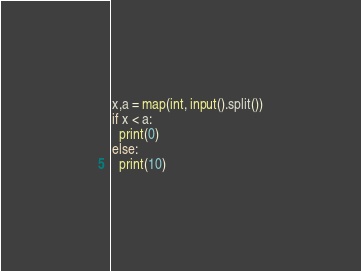<code> <loc_0><loc_0><loc_500><loc_500><_Python_>x,a = map(int, input().split())
if x < a:
  print(0)
else:
  print(10)</code> 